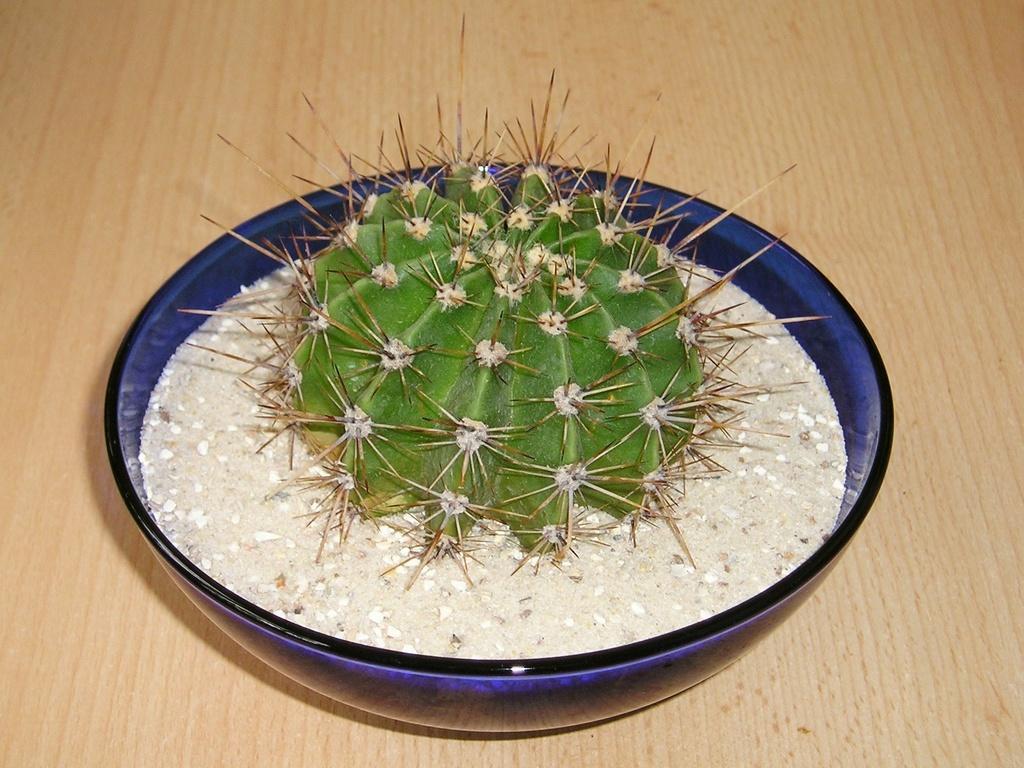How would you summarize this image in a sentence or two? In this image I can see a cream colored surface and on it I can see a blue colored bowl. In the bowl I can see a plant which is green, cream and brown in color. 